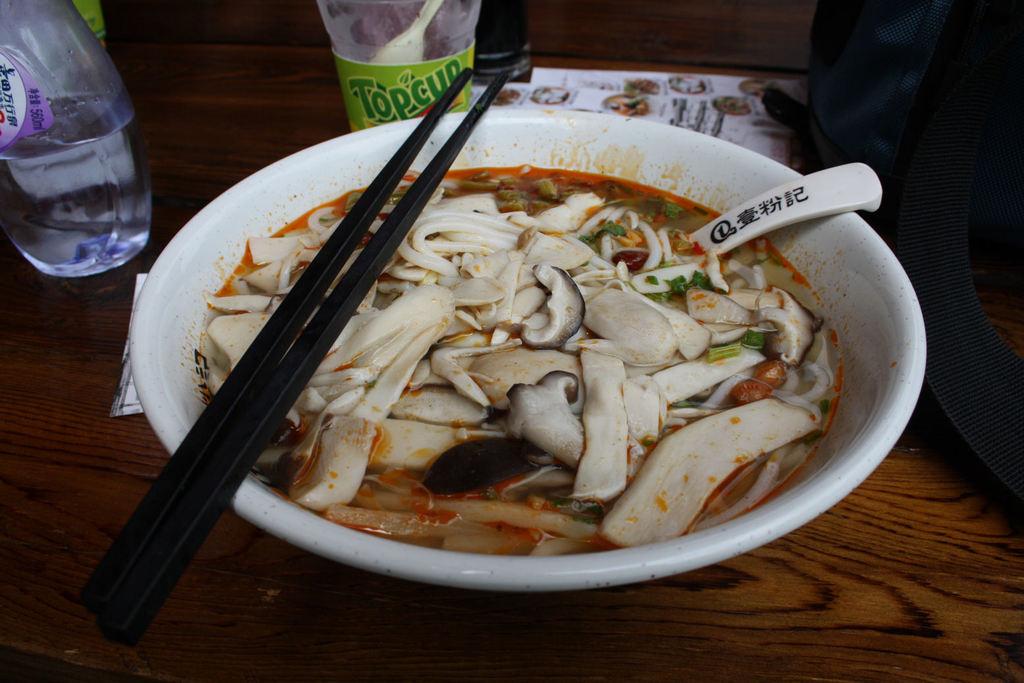What drink is that?
Provide a short and direct response. Topcup. 